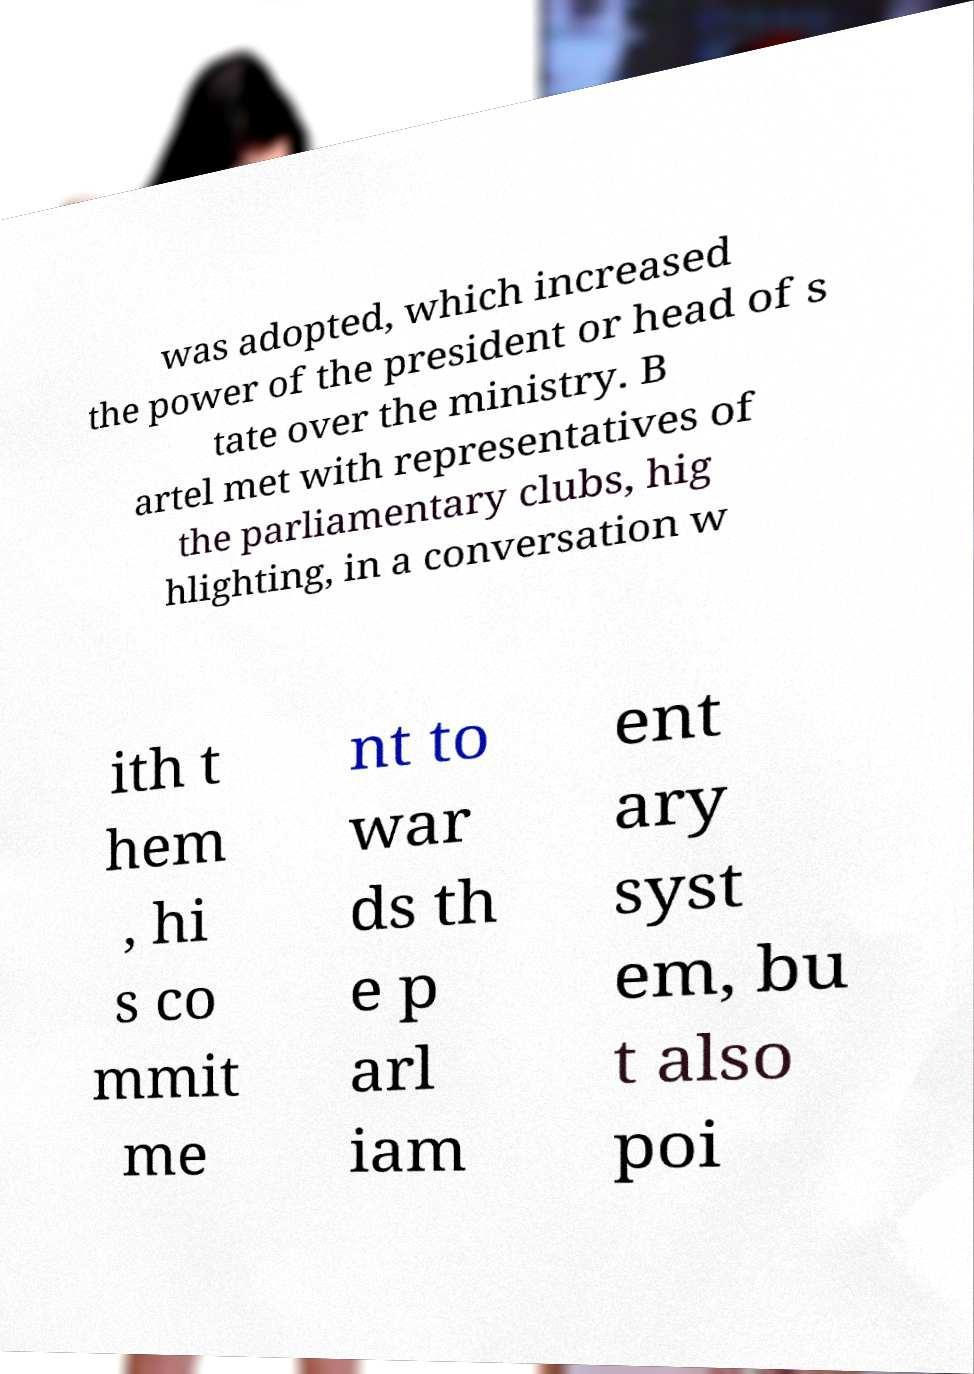Please read and relay the text visible in this image. What does it say? was adopted, which increased the power of the president or head of s tate over the ministry. B artel met with representatives of the parliamentary clubs, hig hlighting, in a conversation w ith t hem , hi s co mmit me nt to war ds th e p arl iam ent ary syst em, bu t also poi 